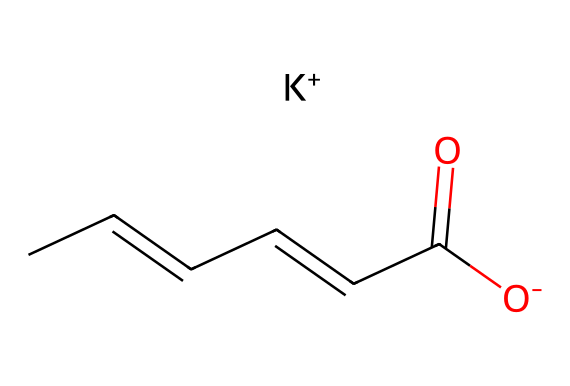What is the functional group present in this compound? The prevalent group in the given compound is the carboxylate ion, indicated by the "C(=O)[O-]" part of the SMILES representation. The carbon atom is double-bonded to an oxygen atom and single-bonded to another oxygen atom that carries a negative charge, which characterizes the carboxylate functional group.
Answer: carboxylate How many carbon atoms are in this molecule? By analyzing the SMILES representation, we see "CC=CC=CC" which denotes a total of 6 carbon atoms connected in a chain. Therefore, counting the carbon bits reveals the total number of carbon atoms.
Answer: six What type of reaction could this preservative be involved in? The presence of the carboxylate group suggests that this compound can participate in esterification reactions with alcohols, where it can react with an alcohol to form an ester, indicating that the chemical can be involved in preservative applications.
Answer: esterification What is the overall charge of this compound? The structure indicates a negative charge due to the presence of the "[O-]" in the carboxylate group. The potassium ion "[K+]" provides a positive charge that balances the negative charge from the carboxylate, leading to an overall neutrality. Since we are specifically focusing on the initial part of the SMILES, it's clear that the compound maintains a balance and is influenced mainly by the carboxylate's behavior in solution.
Answer: neutral What role does the potassium play in this preservative? The potassium ion acts as a counterion to the negatively charged carboxylate group, helping to stabilize the compound in solution. In preservative applications, it can aid in solubility and bioavailability of the preservative compounds, critical for their effectiveness in art supplies.
Answer: counterion 